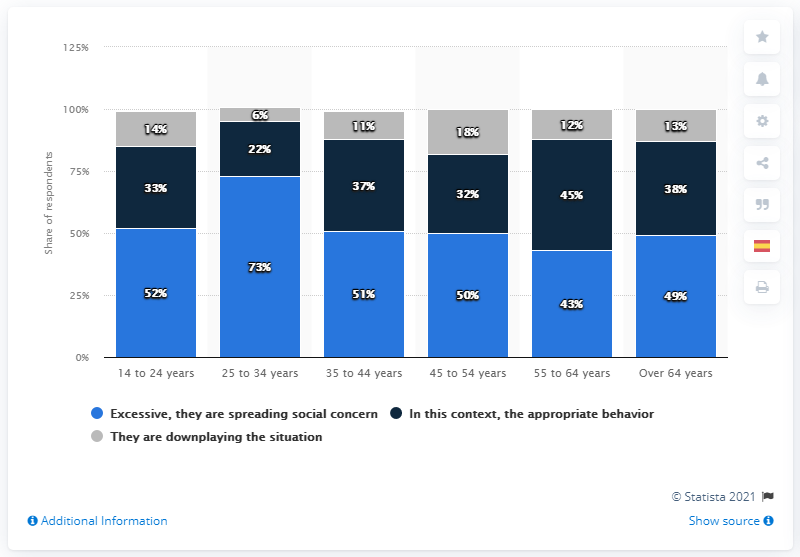Give some essential details in this illustration. The use of gray color suggests that the situation is being downplayed. What is the difference between the maximum and minimum percentage of gray in a bar? 